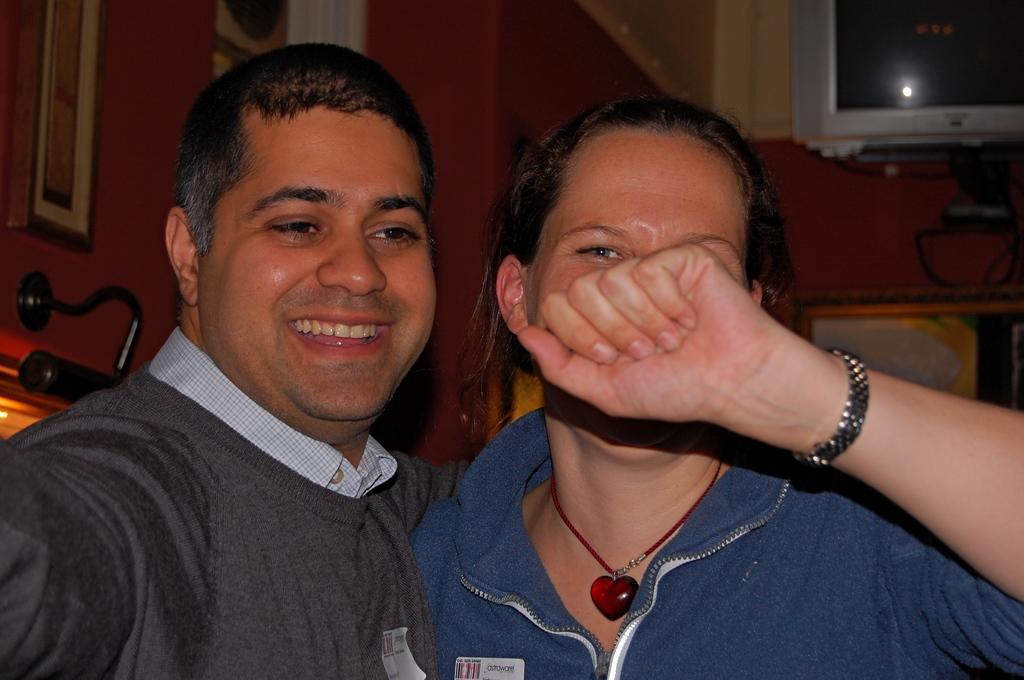Please provide a concise description of this image. This image consists of two persons. This looks like a room. There is light on the left side. 